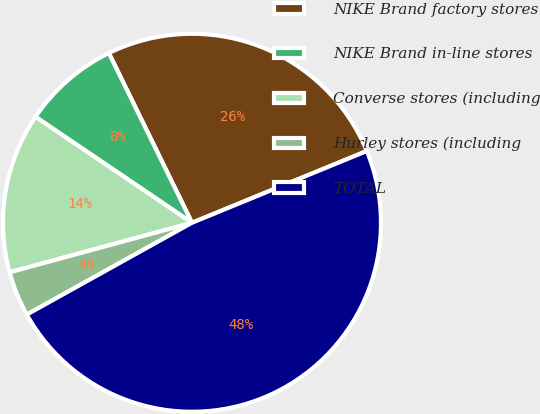Convert chart. <chart><loc_0><loc_0><loc_500><loc_500><pie_chart><fcel>NIKE Brand factory stores<fcel>NIKE Brand in-line stores<fcel>Converse stores (including<fcel>Hurley stores (including<fcel>TOTAL<nl><fcel>26.05%<fcel>8.28%<fcel>13.69%<fcel>3.85%<fcel>48.12%<nl></chart> 